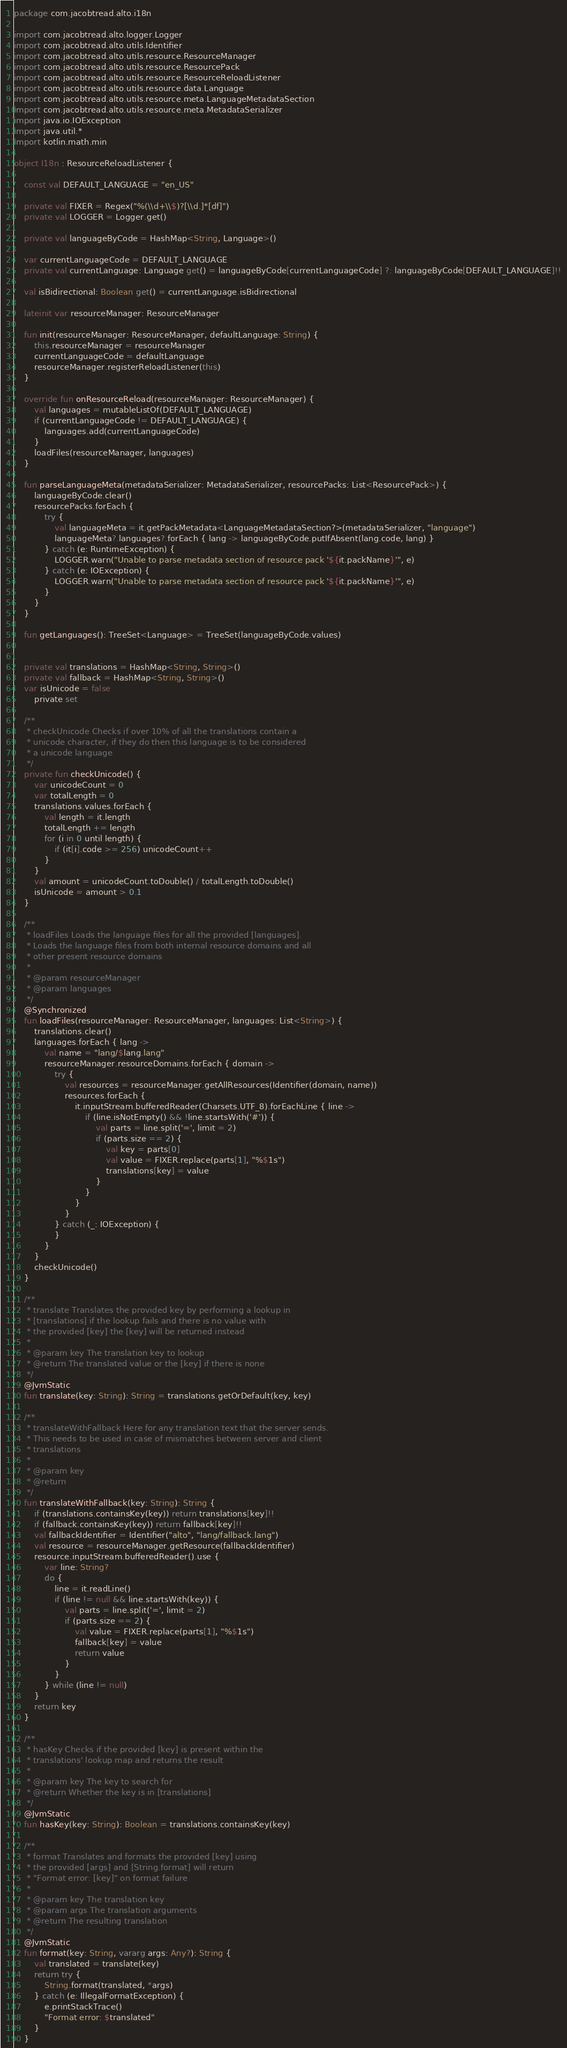<code> <loc_0><loc_0><loc_500><loc_500><_Kotlin_>package com.jacobtread.alto.i18n

import com.jacobtread.alto.logger.Logger
import com.jacobtread.alto.utils.Identifier
import com.jacobtread.alto.utils.resource.ResourceManager
import com.jacobtread.alto.utils.resource.ResourcePack
import com.jacobtread.alto.utils.resource.ResourceReloadListener
import com.jacobtread.alto.utils.resource.data.Language
import com.jacobtread.alto.utils.resource.meta.LanguageMetadataSection
import com.jacobtread.alto.utils.resource.meta.MetadataSerializer
import java.io.IOException
import java.util.*
import kotlin.math.min

object I18n : ResourceReloadListener {

    const val DEFAULT_LANGUAGE = "en_US"

    private val FIXER = Regex("%(\\d+\\$)?[\\d.]*[df]")
    private val LOGGER = Logger.get()

    private val languageByCode = HashMap<String, Language>()

    var currentLanguageCode = DEFAULT_LANGUAGE
    private val currentLanguage: Language get() = languageByCode[currentLanguageCode] ?: languageByCode[DEFAULT_LANGUAGE]!!

    val isBidirectional: Boolean get() = currentLanguage.isBidirectional

    lateinit var resourceManager: ResourceManager

    fun init(resourceManager: ResourceManager, defaultLanguage: String) {
        this.resourceManager = resourceManager
        currentLanguageCode = defaultLanguage
        resourceManager.registerReloadListener(this)
    }

    override fun onResourceReload(resourceManager: ResourceManager) {
        val languages = mutableListOf(DEFAULT_LANGUAGE)
        if (currentLanguageCode != DEFAULT_LANGUAGE) {
            languages.add(currentLanguageCode)
        }
        loadFiles(resourceManager, languages)
    }

    fun parseLanguageMeta(metadataSerializer: MetadataSerializer, resourcePacks: List<ResourcePack>) {
        languageByCode.clear()
        resourcePacks.forEach {
            try {
                val languageMeta = it.getPackMetadata<LanguageMetadataSection?>(metadataSerializer, "language")
                languageMeta?.languages?.forEach { lang -> languageByCode.putIfAbsent(lang.code, lang) }
            } catch (e: RuntimeException) {
                LOGGER.warn("Unable to parse metadata section of resource pack '${it.packName}'", e)
            } catch (e: IOException) {
                LOGGER.warn("Unable to parse metadata section of resource pack '${it.packName}'", e)
            }
        }
    }

    fun getLanguages(): TreeSet<Language> = TreeSet(languageByCode.values)


    private val translations = HashMap<String, String>()
    private val fallback = HashMap<String, String>()
    var isUnicode = false
        private set

    /**
     * checkUnicode Checks if over 10% of all the translations contain a
     * unicode character, if they do then this language is to be considered
     * a unicode language
     */
    private fun checkUnicode() {
        var unicodeCount = 0
        var totalLength = 0
        translations.values.forEach {
            val length = it.length
            totalLength += length
            for (i in 0 until length) {
                if (it[i].code >= 256) unicodeCount++
            }
        }
        val amount = unicodeCount.toDouble() / totalLength.toDouble()
        isUnicode = amount > 0.1
    }

    /**
     * loadFiles Loads the language files for all the provided [languages].
     * Loads the language files from both internal resource domains and all
     * other present resource domains
     *
     * @param resourceManager
     * @param languages
     */
    @Synchronized
    fun loadFiles(resourceManager: ResourceManager, languages: List<String>) {
        translations.clear()
        languages.forEach { lang ->
            val name = "lang/$lang.lang"
            resourceManager.resourceDomains.forEach { domain ->
                try {
                    val resources = resourceManager.getAllResources(Identifier(domain, name))
                    resources.forEach {
                        it.inputStream.bufferedReader(Charsets.UTF_8).forEachLine { line ->
                            if (line.isNotEmpty() && !line.startsWith('#')) {
                                val parts = line.split('=', limit = 2)
                                if (parts.size == 2) {
                                    val key = parts[0]
                                    val value = FIXER.replace(parts[1], "%$1s")
                                    translations[key] = value
                                }
                            }
                        }
                    }
                } catch (_: IOException) {
                }
            }
        }
        checkUnicode()
    }

    /**
     * translate Translates the provided key by performing a lookup in
     * [translations] if the lookup fails and there is no value with
     * the provided [key] the [key] will be returned instead
     *
     * @param key The translation key to lookup
     * @return The translated value or the [key] if there is none
     */
    @JvmStatic
    fun translate(key: String): String = translations.getOrDefault(key, key)

    /**
     * translateWithFallback Here for any translation text that the server sends.
     * This needs to be used in case of mismatches between server and client
     * translations
     *
     * @param key
     * @return
     */
    fun translateWithFallback(key: String): String {
        if (translations.containsKey(key)) return translations[key]!!
        if (fallback.containsKey(key)) return fallback[key]!!
        val fallbackIdentifier = Identifier("alto", "lang/fallback.lang")
        val resource = resourceManager.getResource(fallbackIdentifier)
        resource.inputStream.bufferedReader().use {
            var line: String?
            do {
                line = it.readLine()
                if (line != null && line.startsWith(key)) {
                    val parts = line.split('=', limit = 2)
                    if (parts.size == 2) {
                        val value = FIXER.replace(parts[1], "%$1s")
                        fallback[key] = value
                        return value
                    }
                }
            } while (line != null)
        }
        return key
    }

    /**
     * hasKey Checks if the provided [key] is present within the
     * translations' lookup map and returns the result
     *
     * @param key The key to search for
     * @return Whether the key is in [translations]
     */
    @JvmStatic
    fun hasKey(key: String): Boolean = translations.containsKey(key)

    /**
     * format Translates and formats the provided [key] using
     * the provided [args] and [String.format] will return
     * "Format error: [key]" on format failure
     *
     * @param key The translation key
     * @param args The translation arguments
     * @return The resulting translation
     */
    @JvmStatic
    fun format(key: String, vararg args: Any?): String {
        val translated = translate(key)
        return try {
            String.format(translated, *args)
        } catch (e: IllegalFormatException) {
            e.printStackTrace()
            "Format error: $translated"
        }
    }
</code> 